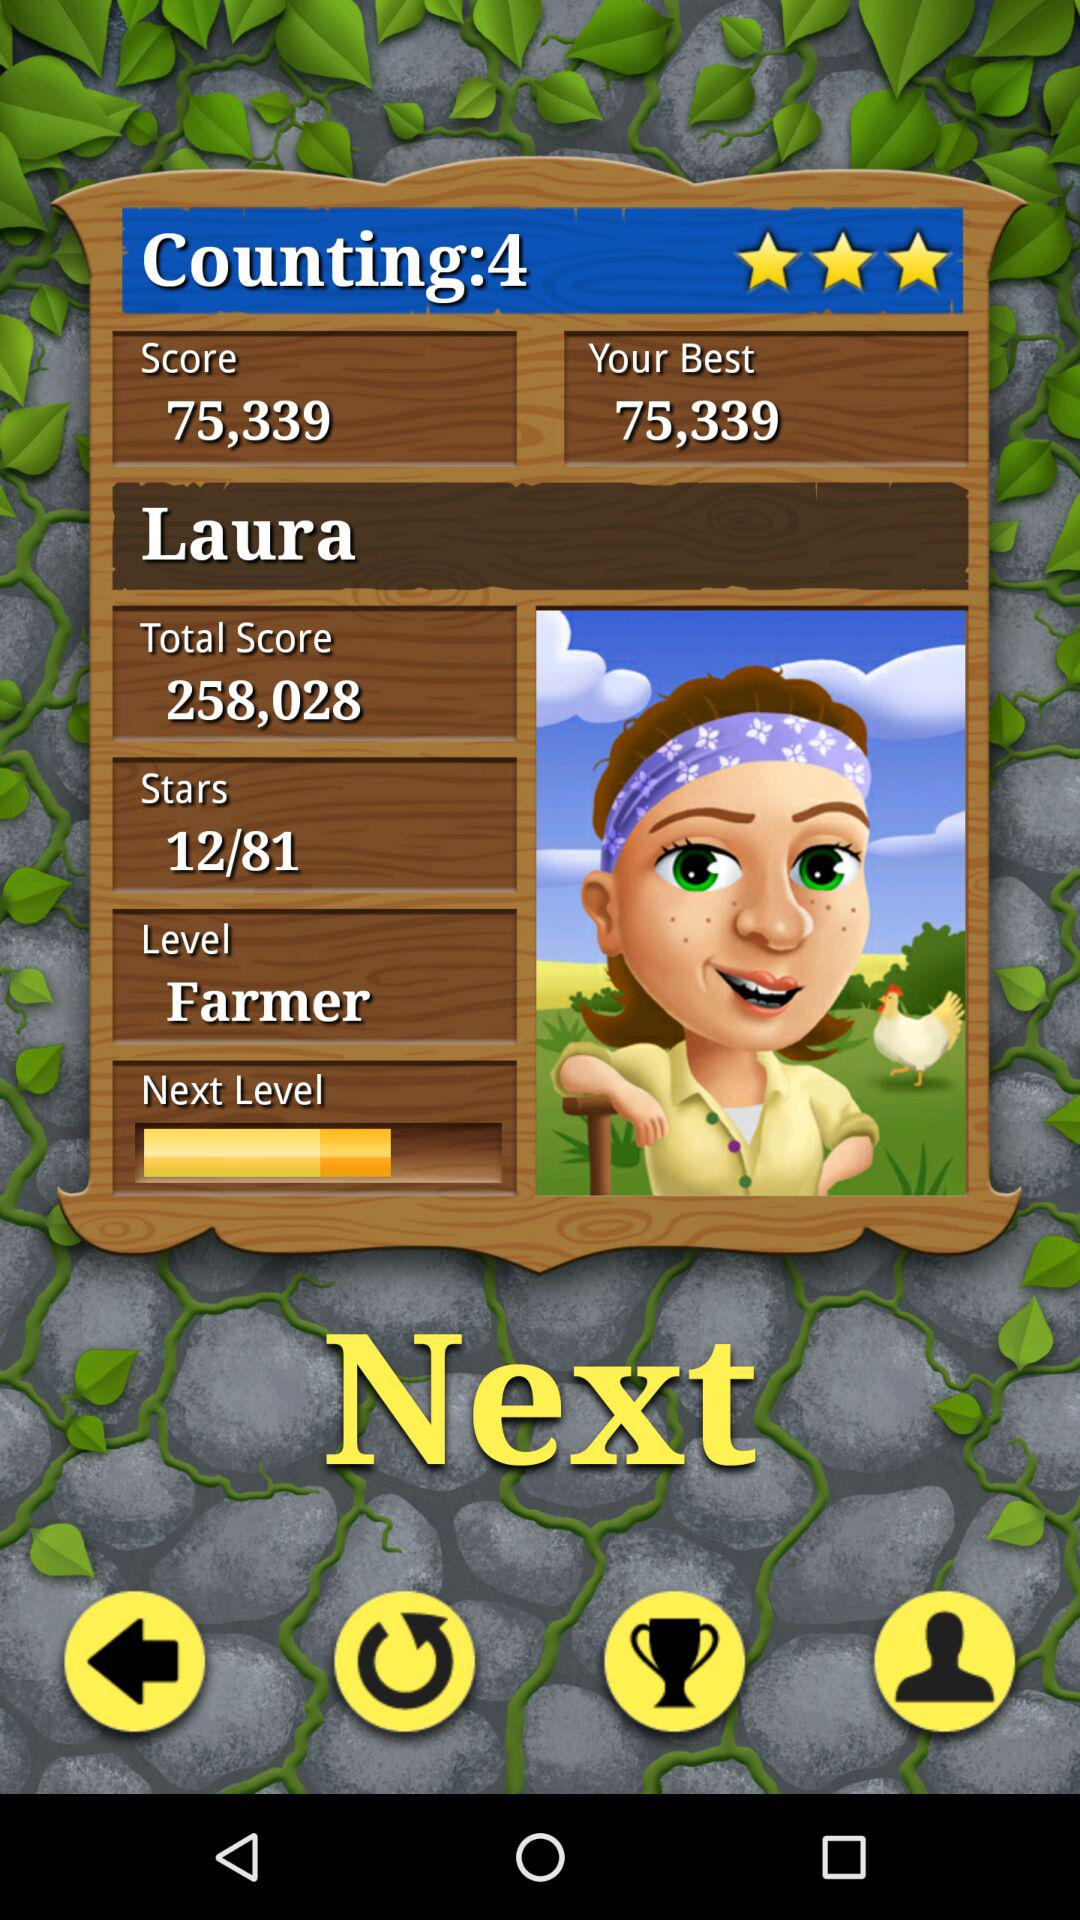How many stars in total are there? There are 81 stars. 